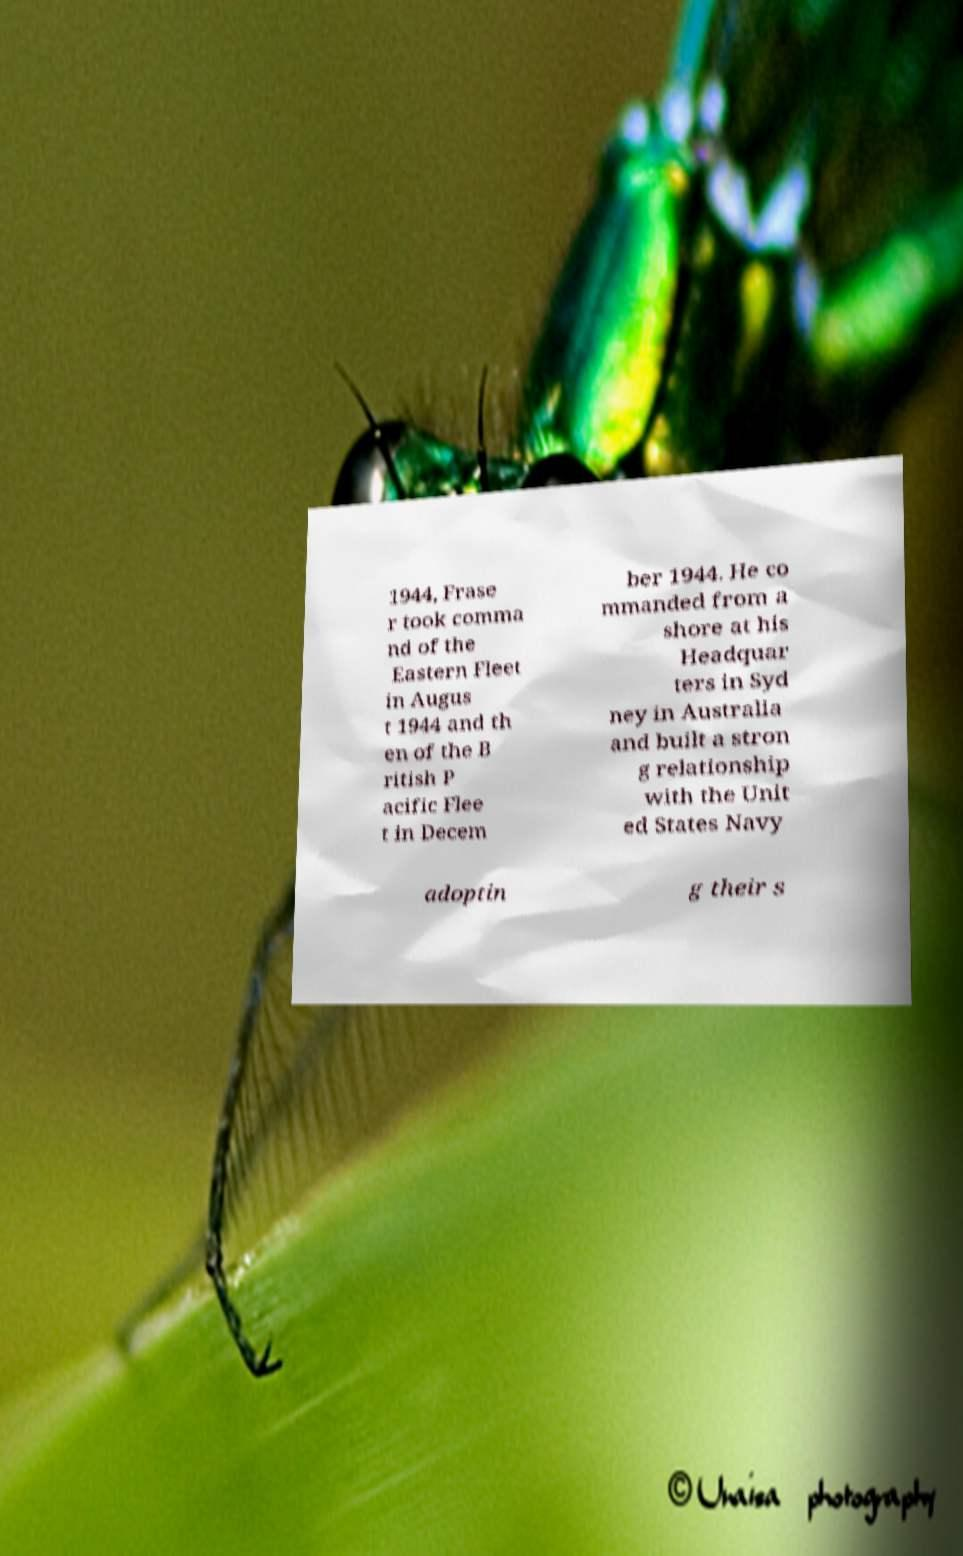Could you assist in decoding the text presented in this image and type it out clearly? 1944, Frase r took comma nd of the Eastern Fleet in Augus t 1944 and th en of the B ritish P acific Flee t in Decem ber 1944. He co mmanded from a shore at his Headquar ters in Syd ney in Australia and built a stron g relationship with the Unit ed States Navy adoptin g their s 